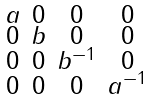Convert formula to latex. <formula><loc_0><loc_0><loc_500><loc_500>\begin{smallmatrix} a & 0 & 0 & 0 \\ 0 & b & 0 & 0 \\ 0 & 0 & b ^ { - 1 } & 0 \\ 0 & 0 & 0 & a ^ { - 1 } \end{smallmatrix}</formula> 